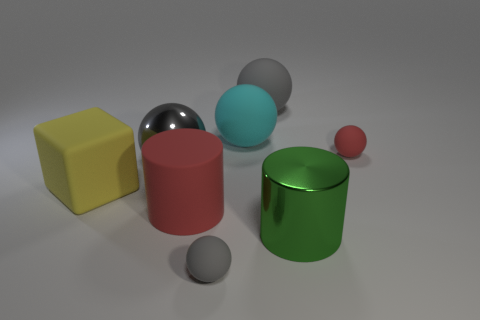What number of other things are there of the same material as the green cylinder
Your response must be concise. 1. What number of red rubber spheres are behind the big cylinder behind the big green metal thing?
Your answer should be very brief. 1. Is there any other thing that is the same shape as the large yellow matte object?
Make the answer very short. No. Is the color of the small thing in front of the red cylinder the same as the big ball that is in front of the tiny red rubber object?
Make the answer very short. Yes. Is the number of metal cylinders less than the number of small green metallic cubes?
Keep it short and to the point. No. The big gray thing to the left of the red matte thing on the left side of the big green shiny cylinder is what shape?
Offer a terse response. Sphere. What shape is the large shiny thing behind the large matte block in front of the shiny object that is left of the cyan matte thing?
Give a very brief answer. Sphere. What number of objects are large rubber objects that are in front of the cyan matte ball or small gray matte things that are on the right side of the large block?
Your answer should be compact. 3. Do the gray shiny object and the yellow object to the left of the red ball have the same size?
Ensure brevity in your answer.  Yes. Do the sphere to the right of the big gray rubber object and the big red thing that is in front of the large gray matte thing have the same material?
Your answer should be compact. Yes. 